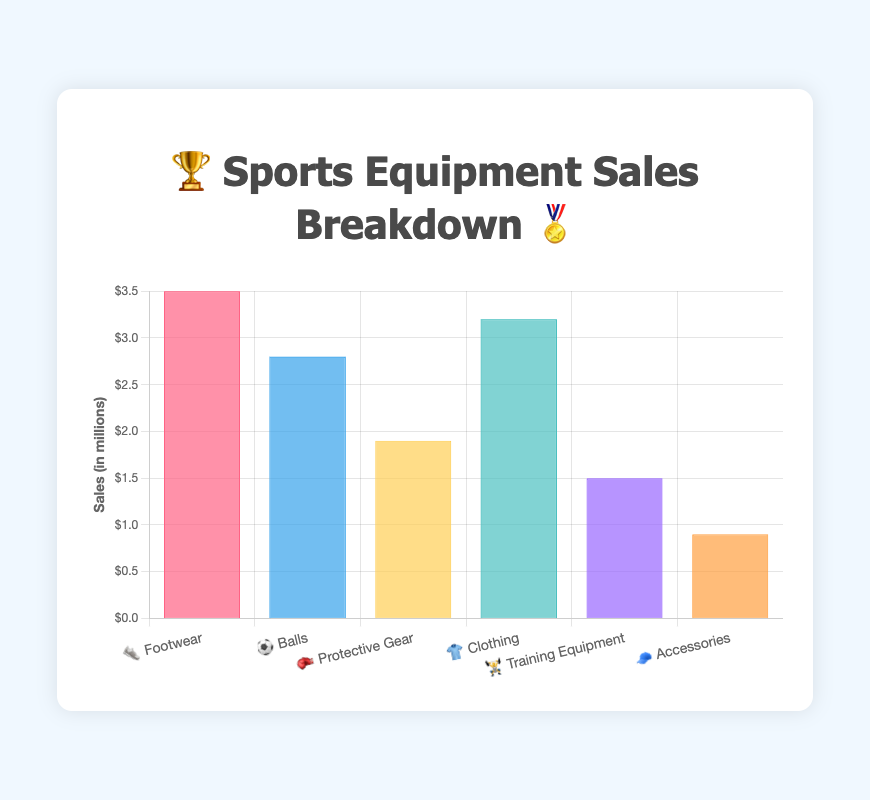What's the highest category of sports equipment sales represented in the chart? The highest category can be identified by the bar with the largest height. Footwear, represented by 👟, has the tallest bar in the chart.
Answer: Footwear Which two categories have similar sales amounts, and what are those amounts? By examining the heights of the bars, we can find that Clothing (👕) and Balls (⚽) have similar sales amounts. The sales for Clothing are $3.2 million, and for Balls, it's $2.8 million.
Answer: Clothing ($3.2M) and Balls ($2.8M) What is the total sales amount combining the categories of Protective Gear and Training Equipment? To find the total sales, add the sales of Protective Gear, $1.9 million, to the sales of Training Equipment, $1.5 million. Thus, $1.9M + $1.5M = $3.4 million.
Answer: $3.4 million Which category has the least sales and how much is it? The category with the least sales is represented by the shortest bar. Accessories, represented by 🧢, has the shortest bar with sales amounting to $0.9 million.
Answer: Accessories ($0.9M) How much more sales does Footwear have compared to Balls? The sales difference between Footwear ($3.5M) and Balls ($2.8M) can be calculated by subtracting the Balls sales from the Footwear sales. So, $3.5M - $2.8M = $0.7 million.
Answer: $0.7 million Rank the categories from highest to lowest sales. By comparing the heights of the bars, we can rank the sales: Footwear ($3.5M), Clothing ($3.2M), Balls ($2.8M), Protective Gear ($1.9M), Training Equipment ($1.5M), and Accessories ($0.9M).
Answer: Footwear, Clothing, Balls, Protective Gear, Training Equipment, Accessories What is the average sales amount for all the categories? To find the average, sum up all sales amounts and divide by the number of categories: ($3.5M + $2.8M + $1.9M + $3.2M + $1.5M + $0.9M) / 6 = $13.8M / 6 ≈ $2.3 million.
Answer: $2.3 million What is the difference between the highest and the lowest sales categories? The difference is found by subtracting the sales of the lowest category (Accessories, $0.9M) from the highest (Footwear, $3.5M). So, $3.5M - $0.9M = $2.6 million.
Answer: $2.6 million 